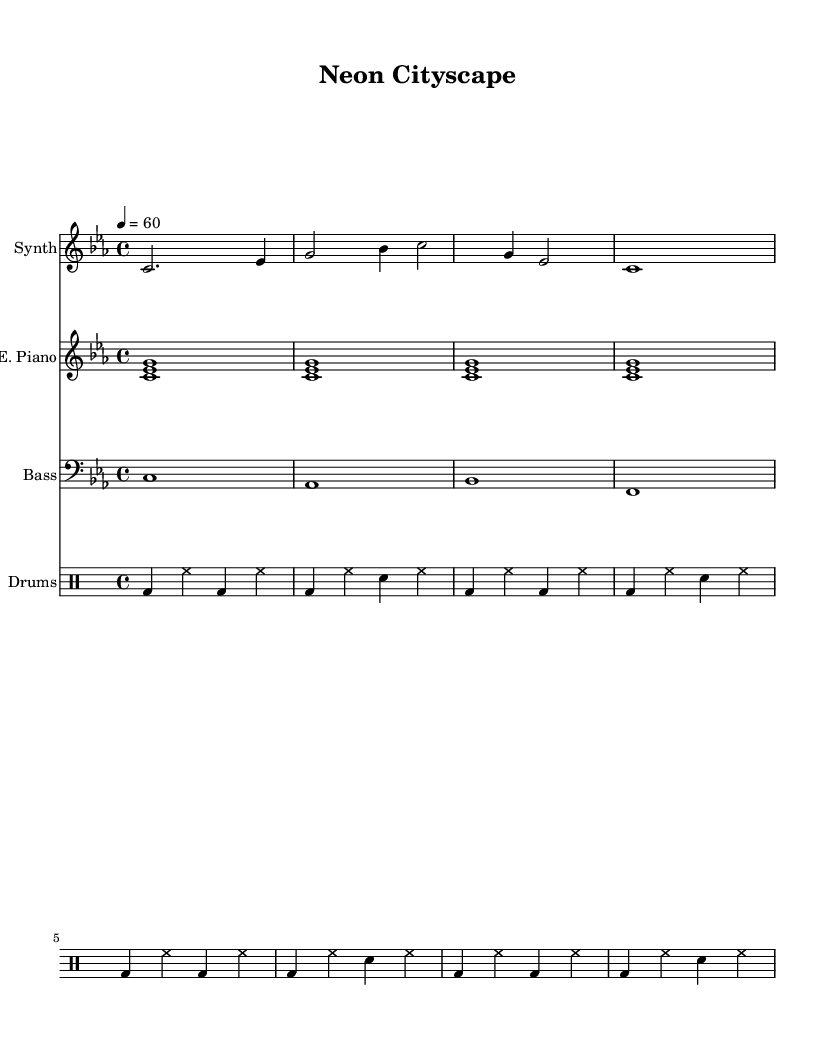What is the key signature of this music? The key signature is C minor, which has three flats: B flat, E flat, and A flat.
Answer: C minor What is the time signature of this piece? The time signature is indicated at the beginning as 4/4, which means there are four beats per measure and the quarter note receives one beat.
Answer: 4/4 What is the tempo marking for this composition? The tempo marking is indicated as "4 = 60," meaning the quarter note should be played at a speed of 60 beats per minute.
Answer: 60 How many measures are there in the synthesizer part? By counting the measures represented in the synthesizer part, there are a total of three measures visible.
Answer: 3 What instruments are featured in this score? The score features a synthesizer, electric piano, bass synth, and drum machine, as indicated by the different staves labeled accordingly.
Answer: Synthesizer, Electric Piano, Bass, Drums Which chord is played in the repeated section of the electric piano? The electric piano plays the chord combination of C, E flat, and G, which form a C minor chord during the repeated section.
Answer: C, E flat, G How many beats does the bass synth play in each measure? The bass synth part is written as a single whole note per measure, thus playing four beats every time.
Answer: 4 